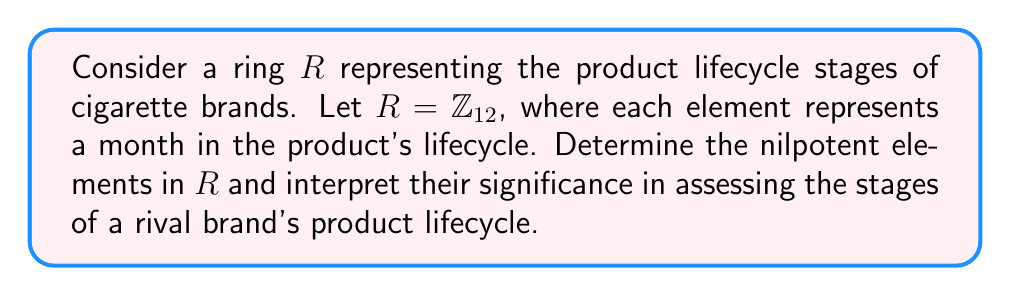Can you answer this question? To solve this problem, we need to follow these steps:

1) Recall that an element $a$ in a ring $R$ is nilpotent if there exists a positive integer $n$ such that $a^n = 0$.

2) In $\mathbb{Z}_{12}$, we need to check each element to see if any power of it equals 0 mod 12.

3) Let's check each element:

   $0^n = 0$ for all $n$, so 0 is nilpotent.
   
   $1^n = 1$ for all $n$, so 1 is not nilpotent.
   
   $2^2 = 4$, $2^3 = 8$, $2^4 = 16 \equiv 4 \pmod{12}$, so 2 is not nilpotent.
   
   $3^2 = 9$, $3^3 = 27 \equiv 3 \pmod{12}$, so 3 is not nilpotent.
   
   $4^2 = 16 \equiv 4 \pmod{12}$, so 4 is not nilpotent.
   
   $5^2 = 25 \equiv 1 \pmod{12}$, so 5 is not nilpotent.
   
   $6^2 = 36 \equiv 0 \pmod{12}$, so 6 is nilpotent.
   
   $7^2 = 49 \equiv 1 \pmod{12}$, so 7 is not nilpotent.
   
   $8^2 = 64 \equiv 4 \pmod{12}$, so 8 is not nilpotent.
   
   $9^2 = 81 \equiv 9 \pmod{12}$, so 9 is not nilpotent.
   
   $10^2 = 100 \equiv 4 \pmod{12}$, so 10 is not nilpotent.
   
   $11^2 = 121 \equiv 1 \pmod{12}$, so 11 is not nilpotent.

4) Therefore, the nilpotent elements in $\mathbb{Z}_{12}$ are 0 and 6.

5) Interpreting this result in the context of product lifecycle stages:
   - 0 represents the initial launch or the end of the lifecycle.
   - 6 represents the midpoint of the lifecycle (6 months in).

   These nilpotent elements indicate critical points in the product lifecycle where significant changes or transitions occur. The element 6 being nilpotent (as $6^2 = 0$) suggests that after two cycles of 6 months, the product returns to its initial state or completes its lifecycle.

This analysis can be used to assess the rival brand's product lifecycle stages, identifying potential vulnerabilities or opportunities for market share gain at these critical points.
Answer: The nilpotent elements in $\mathbb{Z}_{12}$ are 0 and 6. These represent critical transition points in the rival brand's product lifecycle at 0 and 6 months, indicating potential opportunities for market share manipulation. 